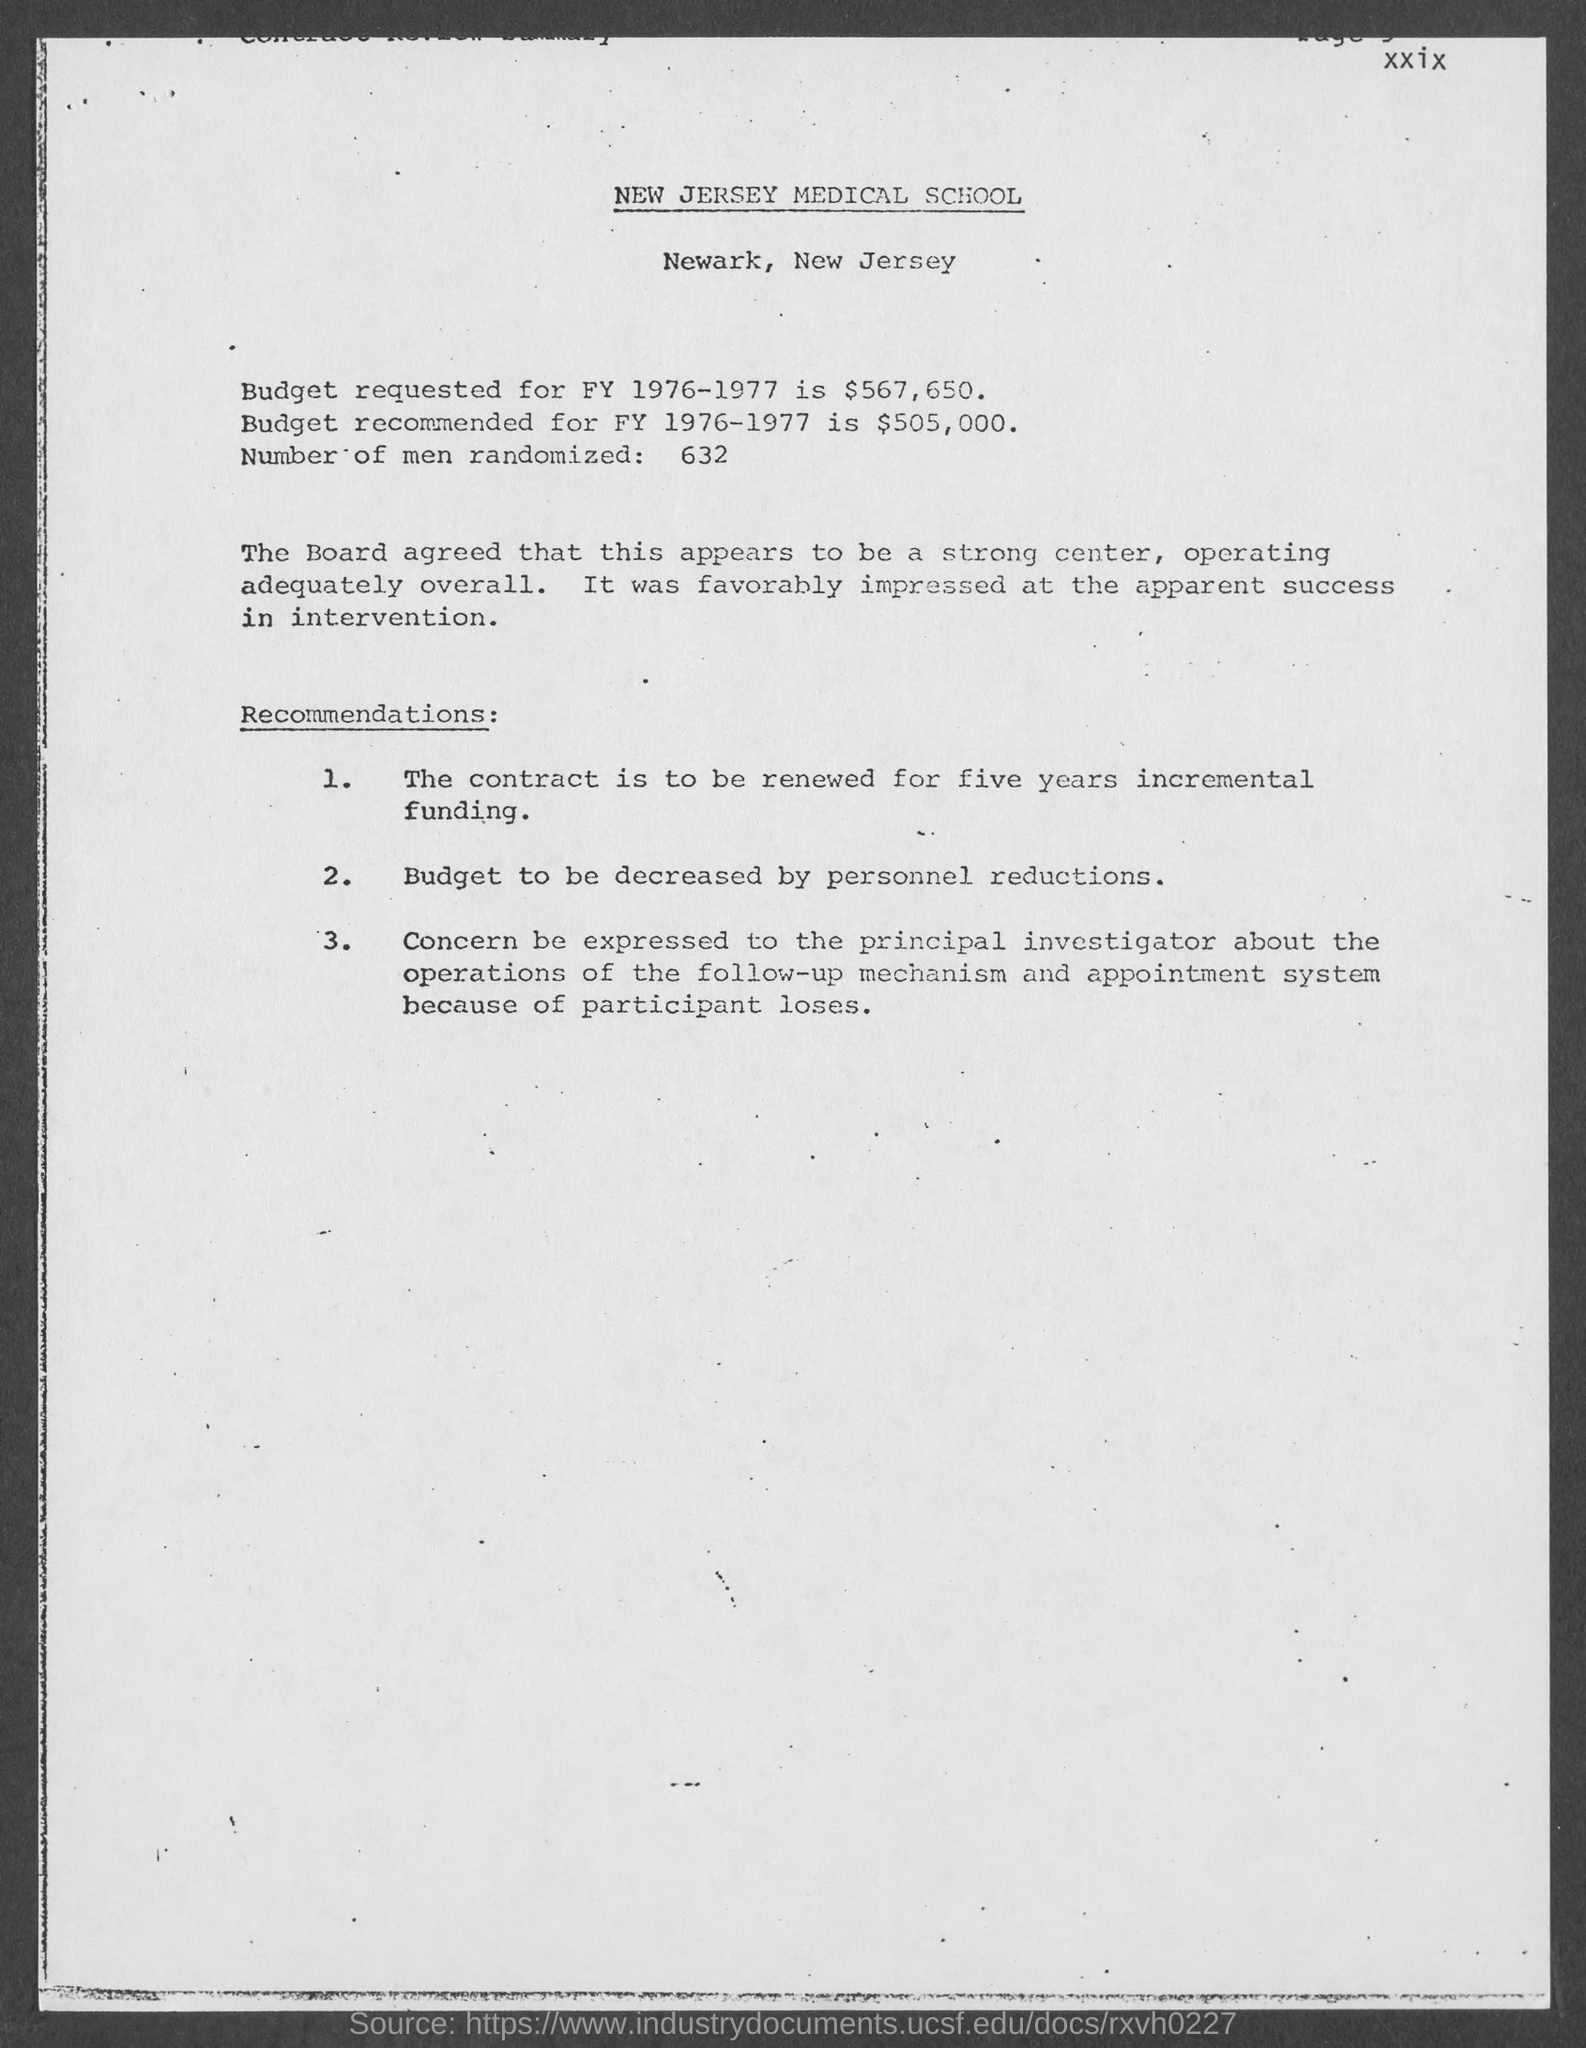What is the number of men randomized as per the document? According to the document, the number of men randomized is precisely 632. This figure is mentioned under the budget recommendations for the fiscal year 1976-1977, suggesting its importance in the context of a medical or research study conducted during that period. 